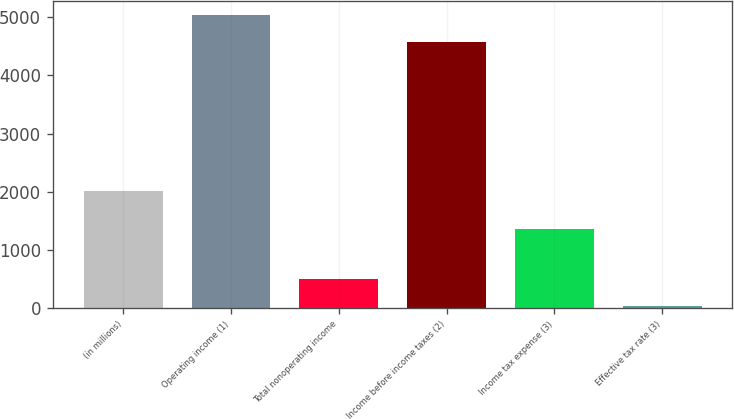Convert chart to OTSL. <chart><loc_0><loc_0><loc_500><loc_500><bar_chart><fcel>(in millions)<fcel>Operating income (1)<fcel>Total nonoperating income<fcel>Income before income taxes (2)<fcel>Income tax expense (3)<fcel>Effective tax rate (3)<nl><fcel>2016<fcel>5030.44<fcel>494.04<fcel>4566<fcel>1352<fcel>29.6<nl></chart> 